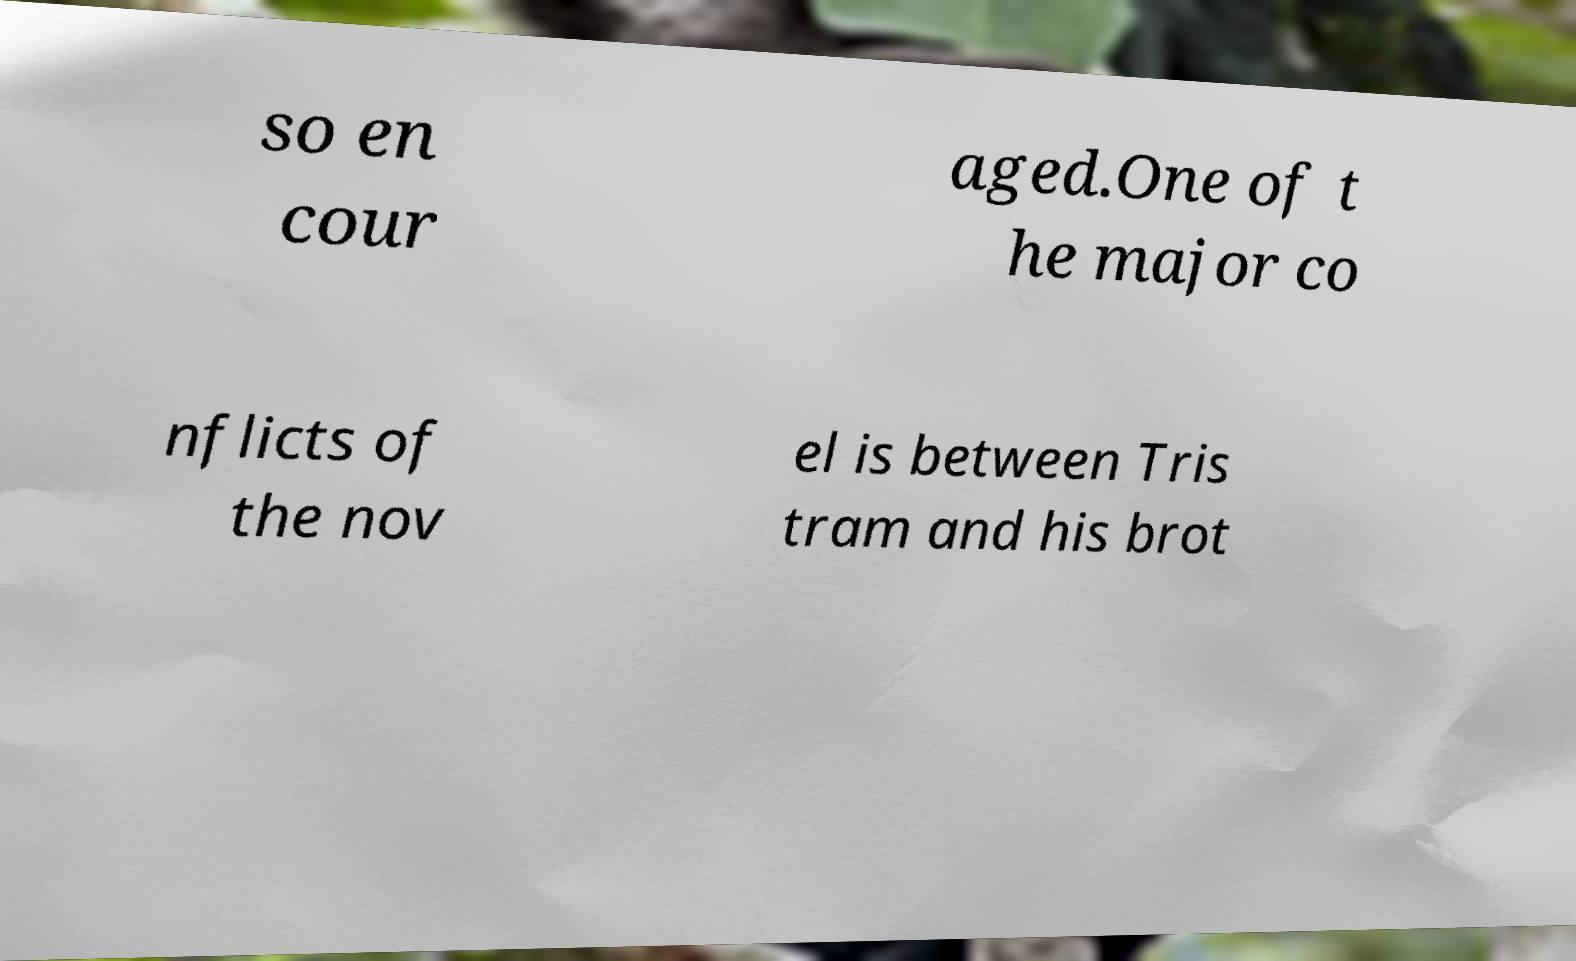I need the written content from this picture converted into text. Can you do that? so en cour aged.One of t he major co nflicts of the nov el is between Tris tram and his brot 